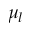Convert formula to latex. <formula><loc_0><loc_0><loc_500><loc_500>\mu _ { l }</formula> 